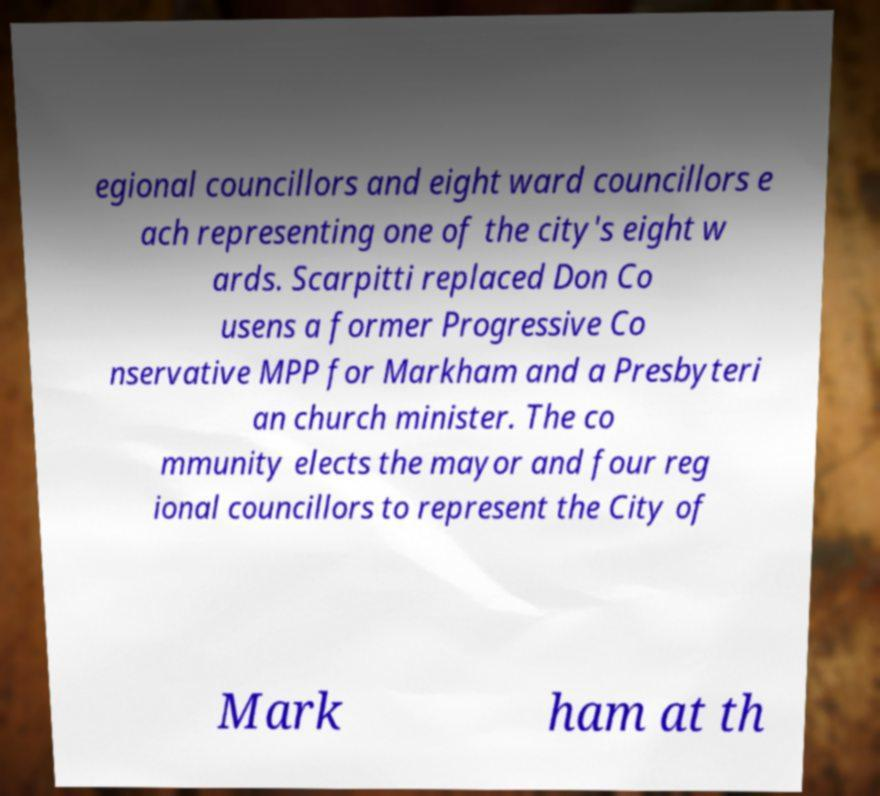What messages or text are displayed in this image? I need them in a readable, typed format. egional councillors and eight ward councillors e ach representing one of the city's eight w ards. Scarpitti replaced Don Co usens a former Progressive Co nservative MPP for Markham and a Presbyteri an church minister. The co mmunity elects the mayor and four reg ional councillors to represent the City of Mark ham at th 